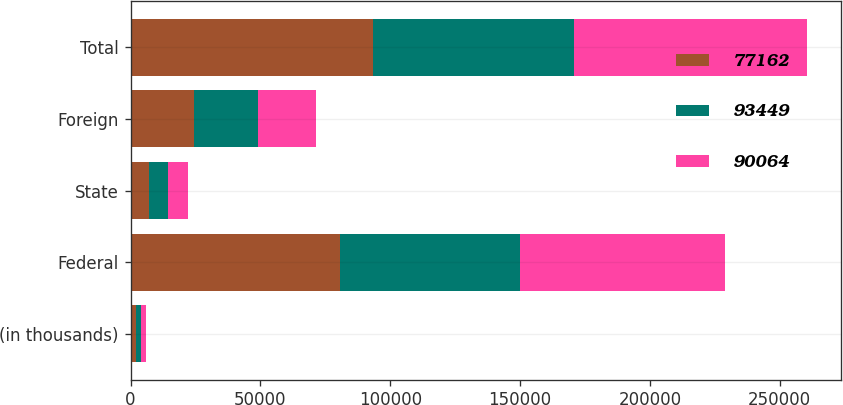<chart> <loc_0><loc_0><loc_500><loc_500><stacked_bar_chart><ecel><fcel>(in thousands)<fcel>Federal<fcel>State<fcel>Foreign<fcel>Total<nl><fcel>77162<fcel>2014<fcel>80620<fcel>7192<fcel>24495<fcel>93449<nl><fcel>93449<fcel>2013<fcel>69268<fcel>7197<fcel>24722<fcel>77162<nl><fcel>90064<fcel>2012<fcel>79028<fcel>7886<fcel>22046<fcel>90064<nl></chart> 